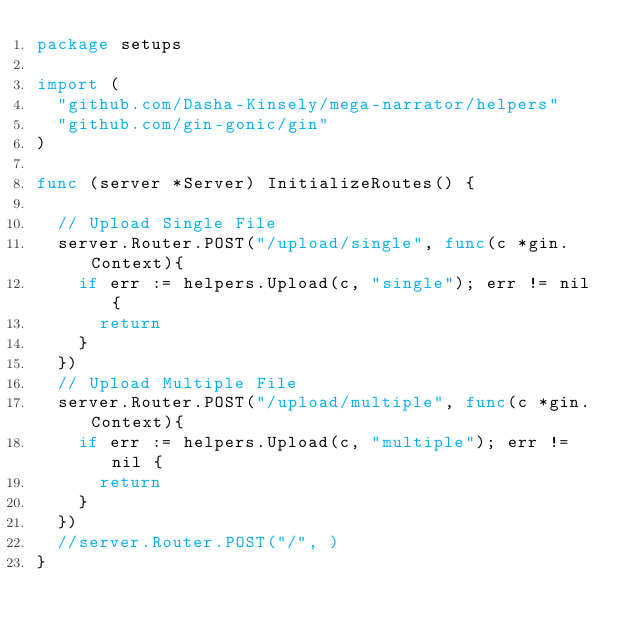Convert code to text. <code><loc_0><loc_0><loc_500><loc_500><_Go_>package setups

import (
	"github.com/Dasha-Kinsely/mega-narrator/helpers"
	"github.com/gin-gonic/gin"
)

func (server *Server) InitializeRoutes() {

	// Upload Single File
	server.Router.POST("/upload/single", func(c *gin.Context){
		if err := helpers.Upload(c, "single"); err != nil {
			return
		}
	})
	// Upload Multiple File
	server.Router.POST("/upload/multiple", func(c *gin.Context){
		if err := helpers.Upload(c, "multiple"); err != nil {
			return
		}
	})
	//server.Router.POST("/", )
}</code> 